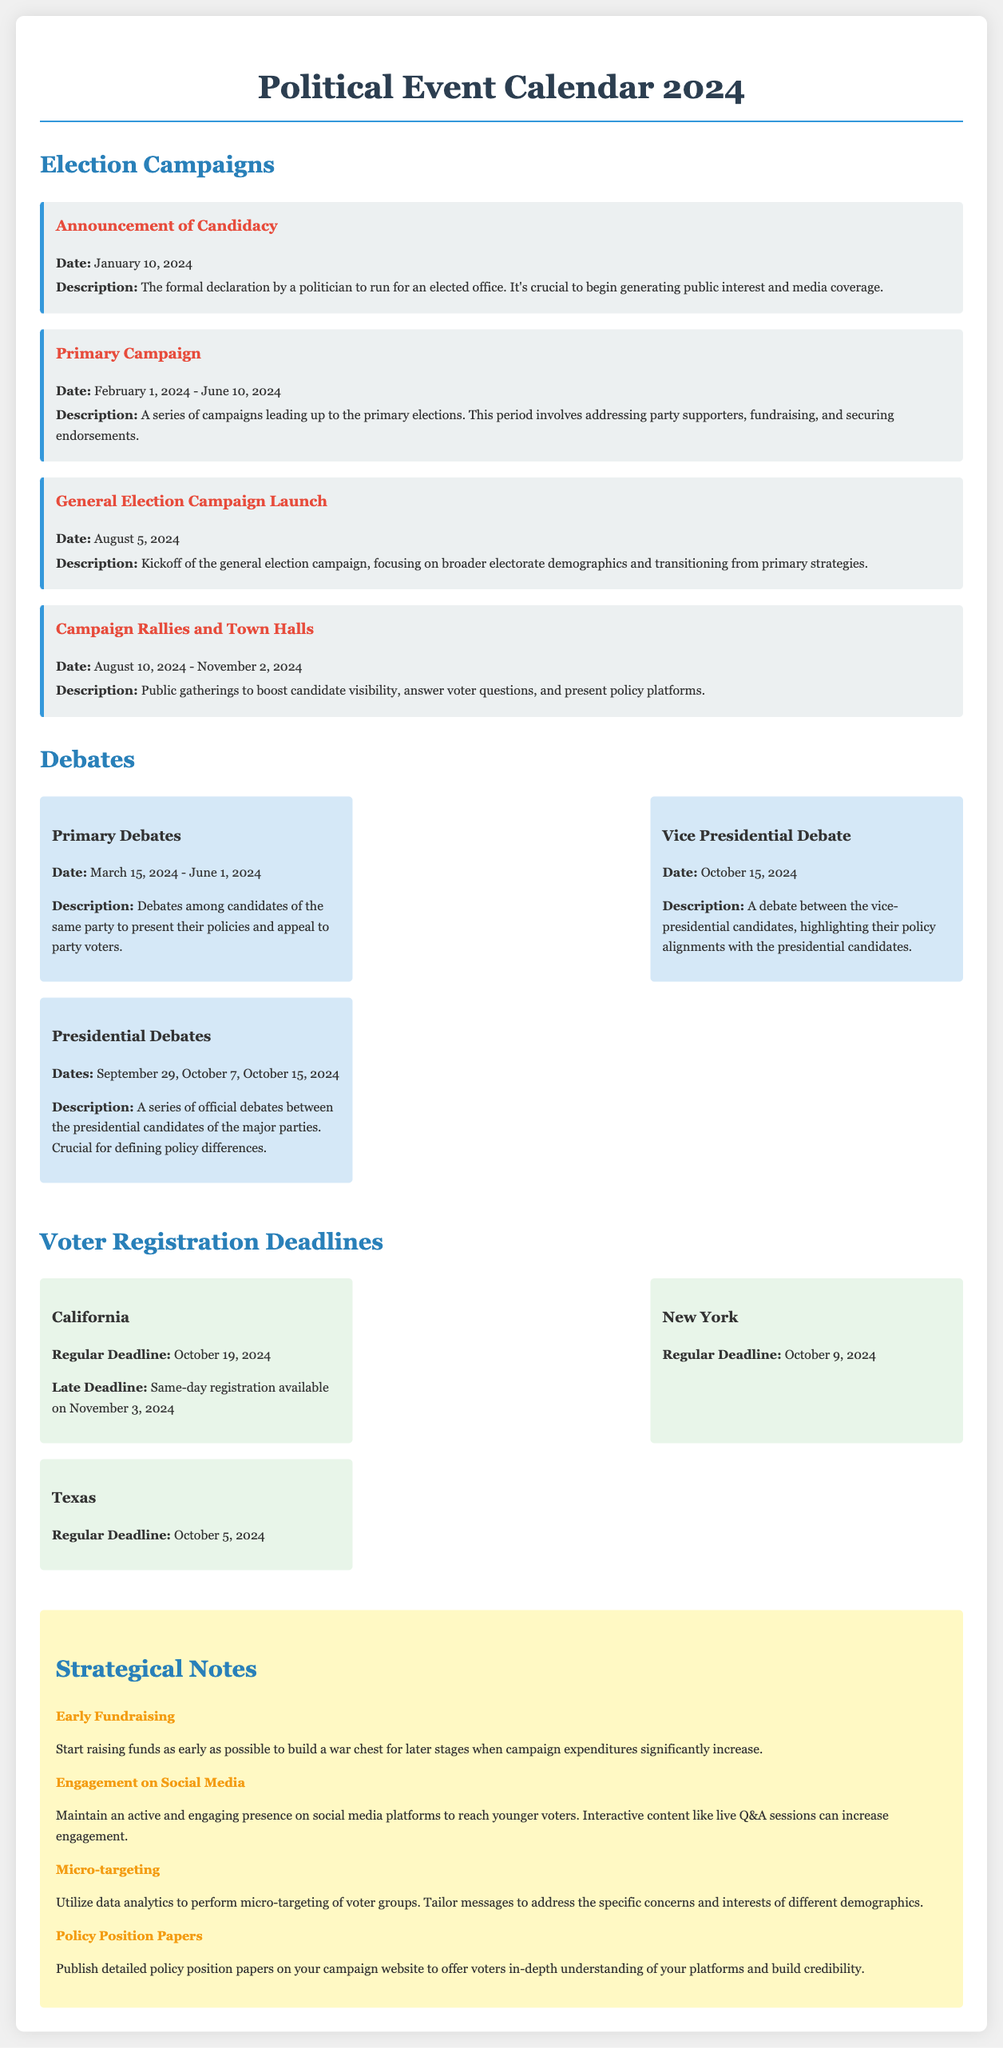What is the date for the announcement of candidacy? The announcement of candidacy is a specific event listed in the document, which states that it occurs on January 10, 2024.
Answer: January 10, 2024 When do the primary campaigns begin? The primary campaign period is clearly indicated in the document as starting on February 1, 2024.
Answer: February 1, 2024 What is the regular voter registration deadline for New York? The document specifies the regular voter registration deadline for New York as October 9, 2024.
Answer: October 9, 2024 How many presidential debates are scheduled? The document lists three presidential debate dates, which requires counting to determine the number of scheduled debates.
Answer: 3 What is a strategy to engage younger voters? The notes section of the document mentions maintaining an active presence on social media as a strategy to engage younger voters.
Answer: Social media What is the late voter registration deadline for California? The document states that California allows same-day registration on November 3, 2024, as a late option.
Answer: November 3, 2024 During what period do the campaign rallies take place? The campaign rallies and town halls span a specific range of dates outlined in the document, from August 10 to November 2, 2024.
Answer: August 10, 2024 - November 2, 2024 What type of events occur from March 15 to June 1, 2024? The document identifies this timeframe as the period for primary debates among candidates.
Answer: Primary Debates 